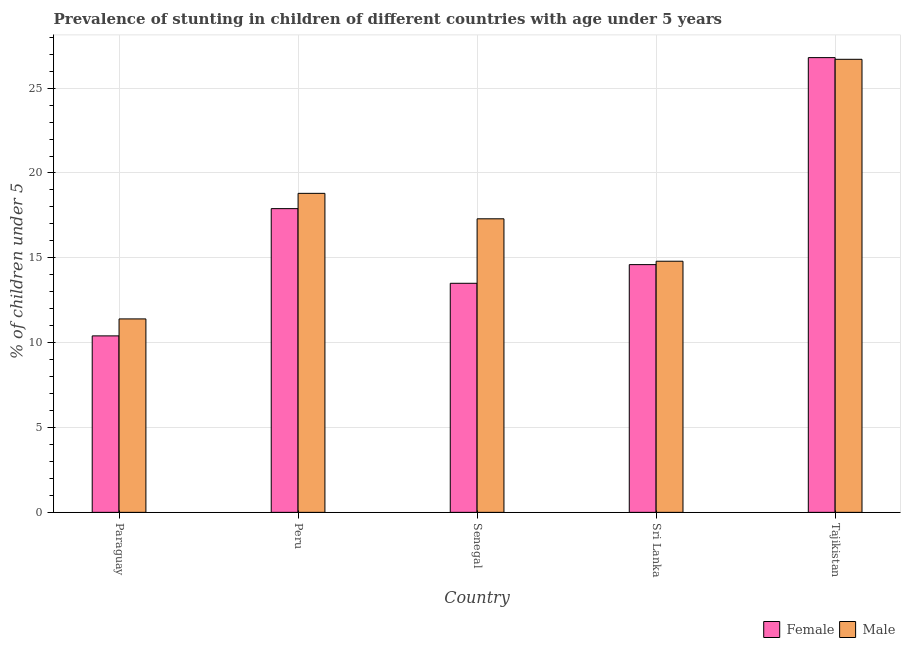How many different coloured bars are there?
Keep it short and to the point. 2. Are the number of bars per tick equal to the number of legend labels?
Provide a succinct answer. Yes. How many bars are there on the 1st tick from the left?
Give a very brief answer. 2. How many bars are there on the 1st tick from the right?
Offer a terse response. 2. What is the label of the 4th group of bars from the left?
Your answer should be compact. Sri Lanka. In how many cases, is the number of bars for a given country not equal to the number of legend labels?
Your answer should be very brief. 0. What is the percentage of stunted male children in Tajikistan?
Provide a succinct answer. 26.7. Across all countries, what is the maximum percentage of stunted female children?
Provide a short and direct response. 26.8. Across all countries, what is the minimum percentage of stunted female children?
Offer a very short reply. 10.4. In which country was the percentage of stunted male children maximum?
Offer a terse response. Tajikistan. In which country was the percentage of stunted female children minimum?
Keep it short and to the point. Paraguay. What is the total percentage of stunted female children in the graph?
Your answer should be compact. 83.2. What is the difference between the percentage of stunted male children in Senegal and that in Tajikistan?
Make the answer very short. -9.4. What is the difference between the percentage of stunted male children in Senegal and the percentage of stunted female children in Peru?
Ensure brevity in your answer.  -0.6. What is the average percentage of stunted male children per country?
Offer a very short reply. 17.8. What is the difference between the percentage of stunted male children and percentage of stunted female children in Tajikistan?
Make the answer very short. -0.1. What is the ratio of the percentage of stunted female children in Paraguay to that in Sri Lanka?
Keep it short and to the point. 0.71. What is the difference between the highest and the second highest percentage of stunted male children?
Provide a succinct answer. 7.9. What is the difference between the highest and the lowest percentage of stunted female children?
Keep it short and to the point. 16.4. In how many countries, is the percentage of stunted female children greater than the average percentage of stunted female children taken over all countries?
Your response must be concise. 2. What does the 2nd bar from the left in Peru represents?
Your answer should be compact. Male. What does the 1st bar from the right in Senegal represents?
Provide a short and direct response. Male. Are all the bars in the graph horizontal?
Give a very brief answer. No. What is the difference between two consecutive major ticks on the Y-axis?
Your response must be concise. 5. Are the values on the major ticks of Y-axis written in scientific E-notation?
Give a very brief answer. No. Does the graph contain any zero values?
Provide a succinct answer. No. How are the legend labels stacked?
Provide a succinct answer. Horizontal. What is the title of the graph?
Ensure brevity in your answer.  Prevalence of stunting in children of different countries with age under 5 years. Does "RDB nonconcessional" appear as one of the legend labels in the graph?
Your response must be concise. No. What is the label or title of the X-axis?
Provide a short and direct response. Country. What is the label or title of the Y-axis?
Your answer should be compact.  % of children under 5. What is the  % of children under 5 of Female in Paraguay?
Give a very brief answer. 10.4. What is the  % of children under 5 of Male in Paraguay?
Ensure brevity in your answer.  11.4. What is the  % of children under 5 in Female in Peru?
Your answer should be compact. 17.9. What is the  % of children under 5 in Male in Peru?
Give a very brief answer. 18.8. What is the  % of children under 5 of Male in Senegal?
Your answer should be very brief. 17.3. What is the  % of children under 5 of Female in Sri Lanka?
Ensure brevity in your answer.  14.6. What is the  % of children under 5 of Male in Sri Lanka?
Ensure brevity in your answer.  14.8. What is the  % of children under 5 of Female in Tajikistan?
Keep it short and to the point. 26.8. What is the  % of children under 5 of Male in Tajikistan?
Ensure brevity in your answer.  26.7. Across all countries, what is the maximum  % of children under 5 in Female?
Ensure brevity in your answer.  26.8. Across all countries, what is the maximum  % of children under 5 of Male?
Your answer should be very brief. 26.7. Across all countries, what is the minimum  % of children under 5 in Female?
Keep it short and to the point. 10.4. Across all countries, what is the minimum  % of children under 5 of Male?
Provide a short and direct response. 11.4. What is the total  % of children under 5 in Female in the graph?
Offer a very short reply. 83.2. What is the total  % of children under 5 in Male in the graph?
Ensure brevity in your answer.  89. What is the difference between the  % of children under 5 of Female in Paraguay and that in Peru?
Offer a terse response. -7.5. What is the difference between the  % of children under 5 in Male in Paraguay and that in Senegal?
Provide a short and direct response. -5.9. What is the difference between the  % of children under 5 in Female in Paraguay and that in Tajikistan?
Make the answer very short. -16.4. What is the difference between the  % of children under 5 of Male in Paraguay and that in Tajikistan?
Ensure brevity in your answer.  -15.3. What is the difference between the  % of children under 5 in Female in Peru and that in Sri Lanka?
Your answer should be compact. 3.3. What is the difference between the  % of children under 5 in Male in Peru and that in Sri Lanka?
Make the answer very short. 4. What is the difference between the  % of children under 5 of Female in Peru and that in Tajikistan?
Give a very brief answer. -8.9. What is the difference between the  % of children under 5 of Female in Sri Lanka and that in Tajikistan?
Give a very brief answer. -12.2. What is the difference between the  % of children under 5 of Male in Sri Lanka and that in Tajikistan?
Your answer should be very brief. -11.9. What is the difference between the  % of children under 5 of Female in Paraguay and the  % of children under 5 of Male in Tajikistan?
Your response must be concise. -16.3. What is the difference between the  % of children under 5 of Female in Peru and the  % of children under 5 of Male in Sri Lanka?
Keep it short and to the point. 3.1. What is the difference between the  % of children under 5 of Female in Senegal and the  % of children under 5 of Male in Sri Lanka?
Keep it short and to the point. -1.3. What is the difference between the  % of children under 5 in Female in Sri Lanka and the  % of children under 5 in Male in Tajikistan?
Offer a very short reply. -12.1. What is the average  % of children under 5 of Female per country?
Your answer should be compact. 16.64. What is the average  % of children under 5 in Male per country?
Make the answer very short. 17.8. What is the difference between the  % of children under 5 in Female and  % of children under 5 in Male in Paraguay?
Ensure brevity in your answer.  -1. What is the difference between the  % of children under 5 in Female and  % of children under 5 in Male in Peru?
Your answer should be very brief. -0.9. What is the difference between the  % of children under 5 in Female and  % of children under 5 in Male in Sri Lanka?
Keep it short and to the point. -0.2. What is the difference between the  % of children under 5 of Female and  % of children under 5 of Male in Tajikistan?
Provide a succinct answer. 0.1. What is the ratio of the  % of children under 5 in Female in Paraguay to that in Peru?
Your answer should be very brief. 0.58. What is the ratio of the  % of children under 5 of Male in Paraguay to that in Peru?
Offer a terse response. 0.61. What is the ratio of the  % of children under 5 in Female in Paraguay to that in Senegal?
Provide a short and direct response. 0.77. What is the ratio of the  % of children under 5 in Male in Paraguay to that in Senegal?
Give a very brief answer. 0.66. What is the ratio of the  % of children under 5 of Female in Paraguay to that in Sri Lanka?
Make the answer very short. 0.71. What is the ratio of the  % of children under 5 of Male in Paraguay to that in Sri Lanka?
Your response must be concise. 0.77. What is the ratio of the  % of children under 5 in Female in Paraguay to that in Tajikistan?
Make the answer very short. 0.39. What is the ratio of the  % of children under 5 of Male in Paraguay to that in Tajikistan?
Provide a short and direct response. 0.43. What is the ratio of the  % of children under 5 in Female in Peru to that in Senegal?
Offer a terse response. 1.33. What is the ratio of the  % of children under 5 in Male in Peru to that in Senegal?
Make the answer very short. 1.09. What is the ratio of the  % of children under 5 of Female in Peru to that in Sri Lanka?
Provide a succinct answer. 1.23. What is the ratio of the  % of children under 5 of Male in Peru to that in Sri Lanka?
Provide a succinct answer. 1.27. What is the ratio of the  % of children under 5 of Female in Peru to that in Tajikistan?
Offer a very short reply. 0.67. What is the ratio of the  % of children under 5 in Male in Peru to that in Tajikistan?
Your answer should be very brief. 0.7. What is the ratio of the  % of children under 5 of Female in Senegal to that in Sri Lanka?
Provide a succinct answer. 0.92. What is the ratio of the  % of children under 5 in Male in Senegal to that in Sri Lanka?
Keep it short and to the point. 1.17. What is the ratio of the  % of children under 5 of Female in Senegal to that in Tajikistan?
Ensure brevity in your answer.  0.5. What is the ratio of the  % of children under 5 in Male in Senegal to that in Tajikistan?
Ensure brevity in your answer.  0.65. What is the ratio of the  % of children under 5 of Female in Sri Lanka to that in Tajikistan?
Your answer should be very brief. 0.54. What is the ratio of the  % of children under 5 of Male in Sri Lanka to that in Tajikistan?
Offer a terse response. 0.55. What is the difference between the highest and the second highest  % of children under 5 of Female?
Your answer should be very brief. 8.9. What is the difference between the highest and the second highest  % of children under 5 in Male?
Provide a short and direct response. 7.9. What is the difference between the highest and the lowest  % of children under 5 in Female?
Keep it short and to the point. 16.4. What is the difference between the highest and the lowest  % of children under 5 of Male?
Your answer should be compact. 15.3. 